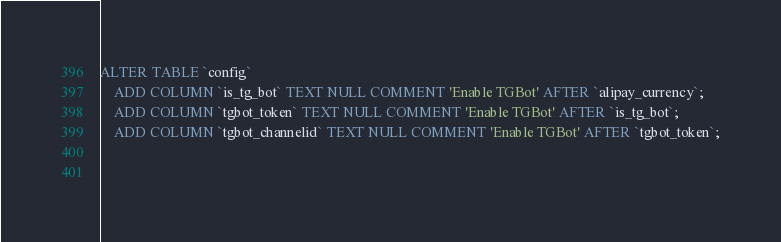Convert code to text. <code><loc_0><loc_0><loc_500><loc_500><_SQL_>ALTER TABLE `config`
	ADD COLUMN `is_tg_bot` TEXT NULL COMMENT 'Enable TGBot' AFTER `alipay_currency`;
	ADD COLUMN `tgbot_token` TEXT NULL COMMENT 'Enable TGBot' AFTER `is_tg_bot`;
	ADD COLUMN `tgbot_channelid` TEXT NULL COMMENT 'Enable TGBot' AFTER `tgbot_token`;

	
</code> 